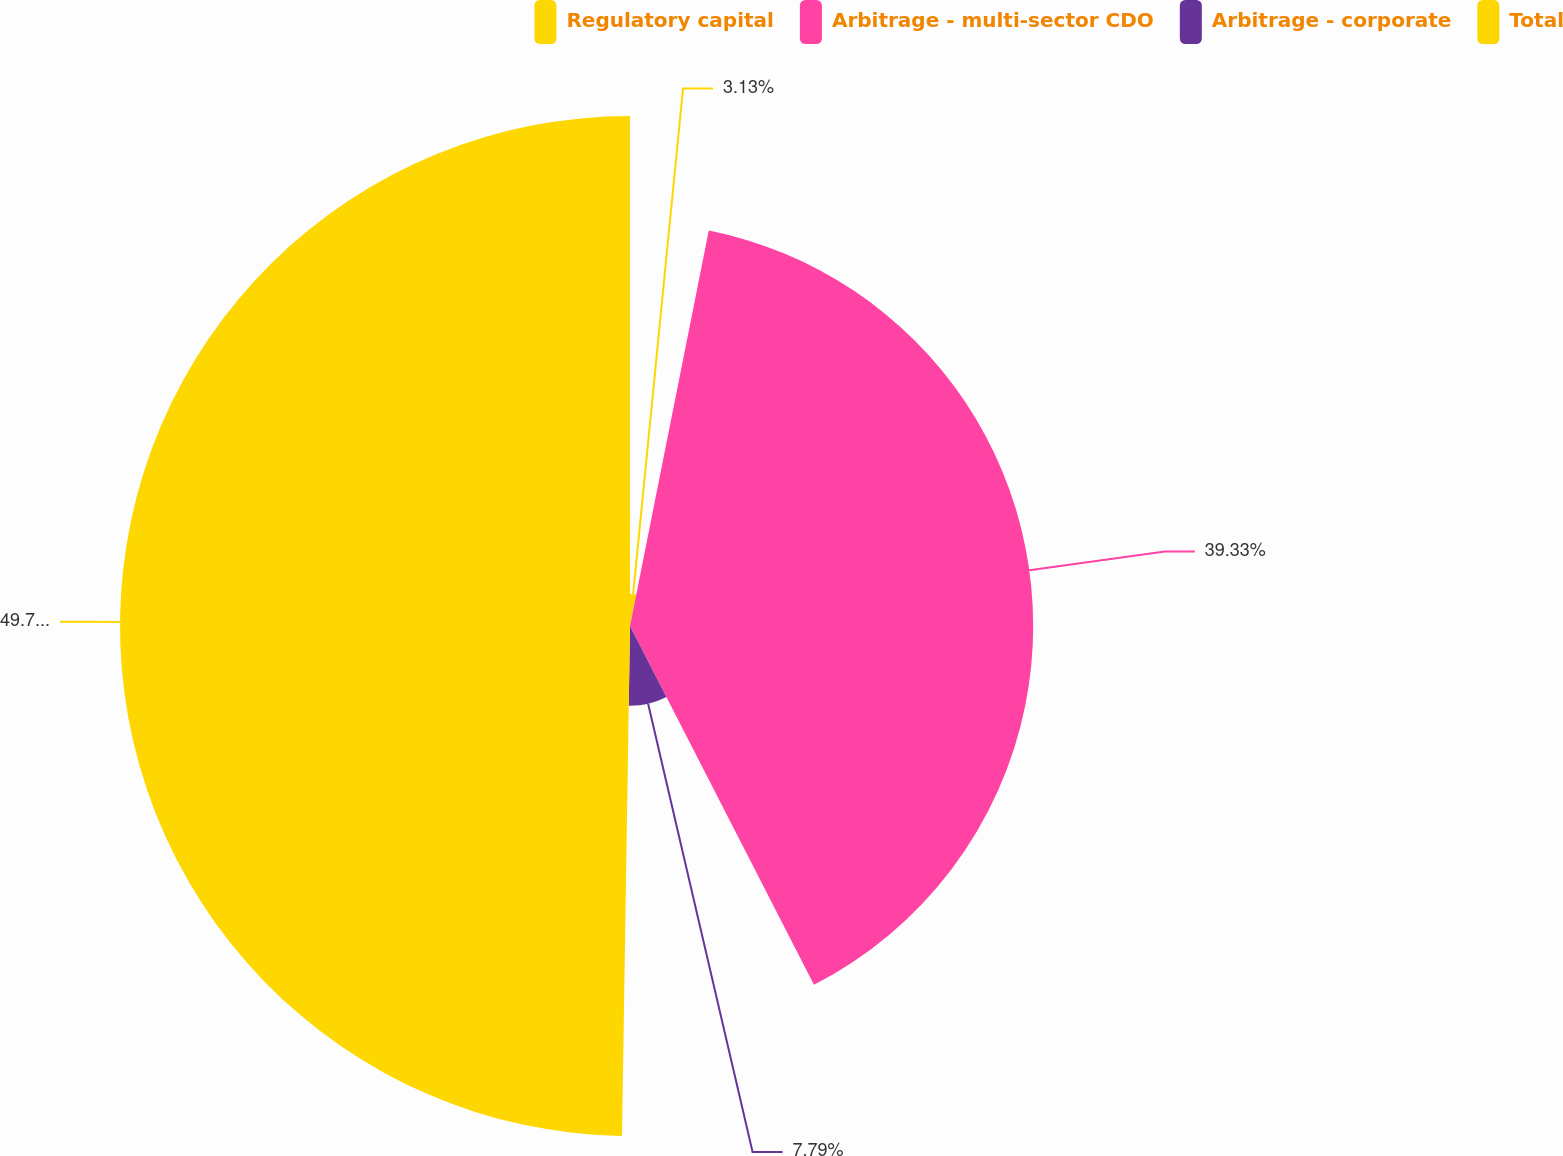Convert chart. <chart><loc_0><loc_0><loc_500><loc_500><pie_chart><fcel>Regulatory capital<fcel>Arbitrage - multi-sector CDO<fcel>Arbitrage - corporate<fcel>Total<nl><fcel>3.13%<fcel>39.33%<fcel>7.79%<fcel>49.75%<nl></chart> 